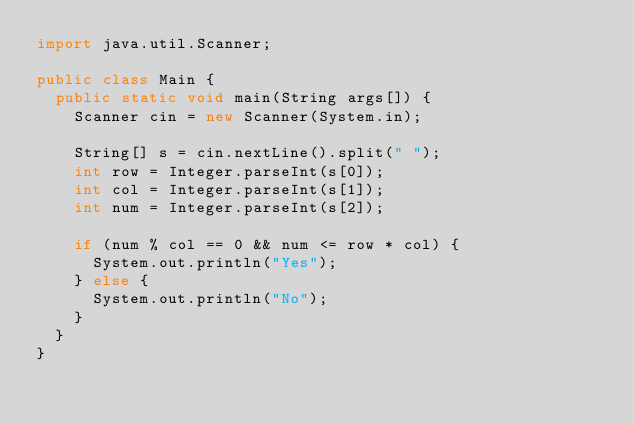<code> <loc_0><loc_0><loc_500><loc_500><_Java_>import java.util.Scanner;

public class Main {
  public static void main(String args[]) {
    Scanner cin = new Scanner(System.in);

    String[] s = cin.nextLine().split(" ");
    int row = Integer.parseInt(s[0]);
    int col = Integer.parseInt(s[1]);
    int num = Integer.parseInt(s[2]);

    if (num % col == 0 && num <= row * col) {
      System.out.println("Yes");
    } else {
      System.out.println("No");
    }
  }
}
</code> 